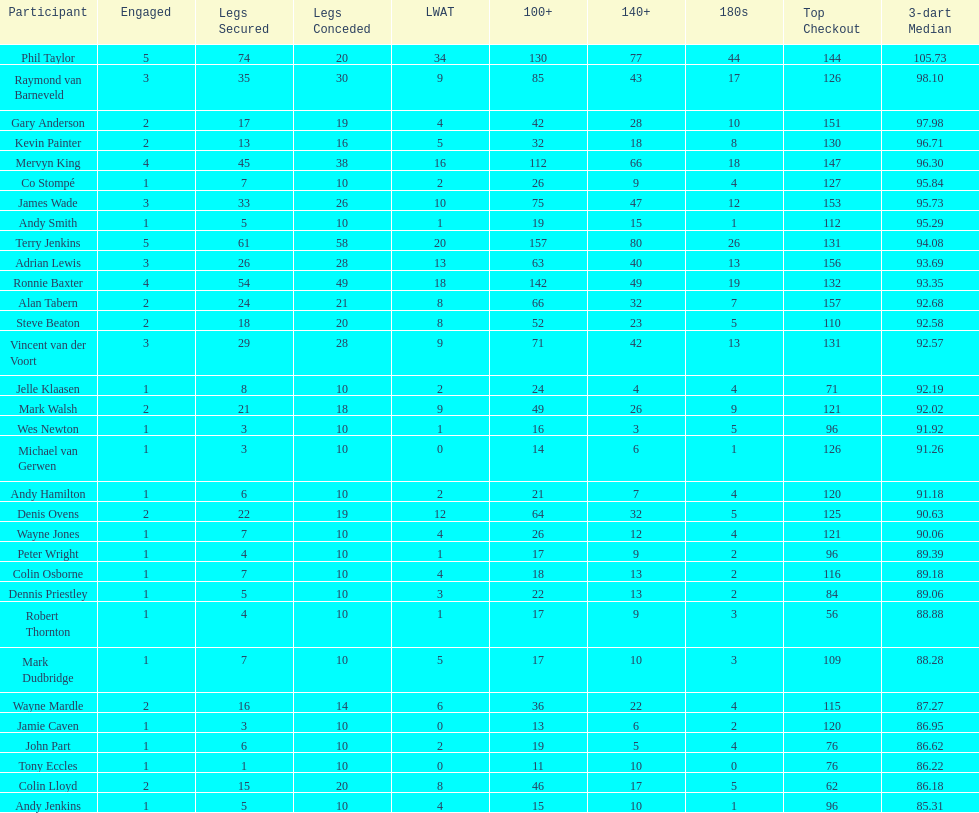Which player has his high checkout as 116? Colin Osborne. 